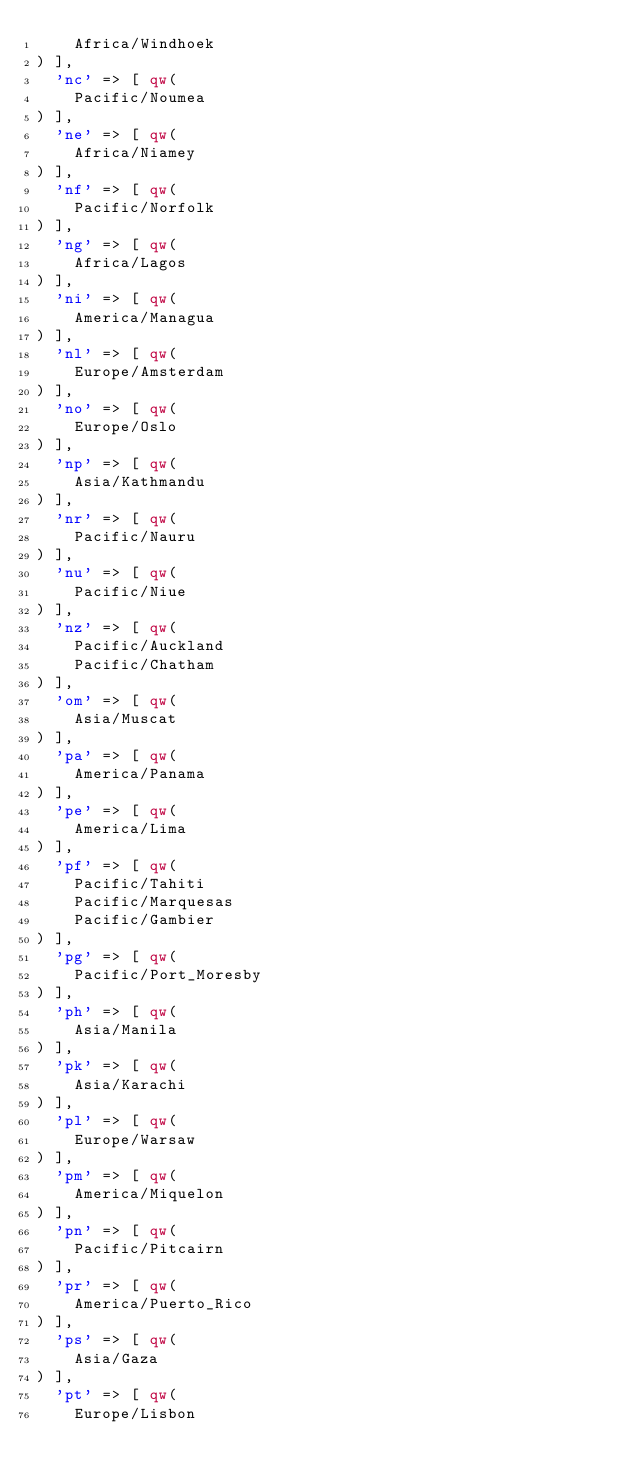<code> <loc_0><loc_0><loc_500><loc_500><_Perl_>    Africa/Windhoek
) ],
  'nc' => [ qw(
    Pacific/Noumea
) ],
  'ne' => [ qw(
    Africa/Niamey
) ],
  'nf' => [ qw(
    Pacific/Norfolk
) ],
  'ng' => [ qw(
    Africa/Lagos
) ],
  'ni' => [ qw(
    America/Managua
) ],
  'nl' => [ qw(
    Europe/Amsterdam
) ],
  'no' => [ qw(
    Europe/Oslo
) ],
  'np' => [ qw(
    Asia/Kathmandu
) ],
  'nr' => [ qw(
    Pacific/Nauru
) ],
  'nu' => [ qw(
    Pacific/Niue
) ],
  'nz' => [ qw(
    Pacific/Auckland
    Pacific/Chatham
) ],
  'om' => [ qw(
    Asia/Muscat
) ],
  'pa' => [ qw(
    America/Panama
) ],
  'pe' => [ qw(
    America/Lima
) ],
  'pf' => [ qw(
    Pacific/Tahiti
    Pacific/Marquesas
    Pacific/Gambier
) ],
  'pg' => [ qw(
    Pacific/Port_Moresby
) ],
  'ph' => [ qw(
    Asia/Manila
) ],
  'pk' => [ qw(
    Asia/Karachi
) ],
  'pl' => [ qw(
    Europe/Warsaw
) ],
  'pm' => [ qw(
    America/Miquelon
) ],
  'pn' => [ qw(
    Pacific/Pitcairn
) ],
  'pr' => [ qw(
    America/Puerto_Rico
) ],
  'ps' => [ qw(
    Asia/Gaza
) ],
  'pt' => [ qw(
    Europe/Lisbon</code> 